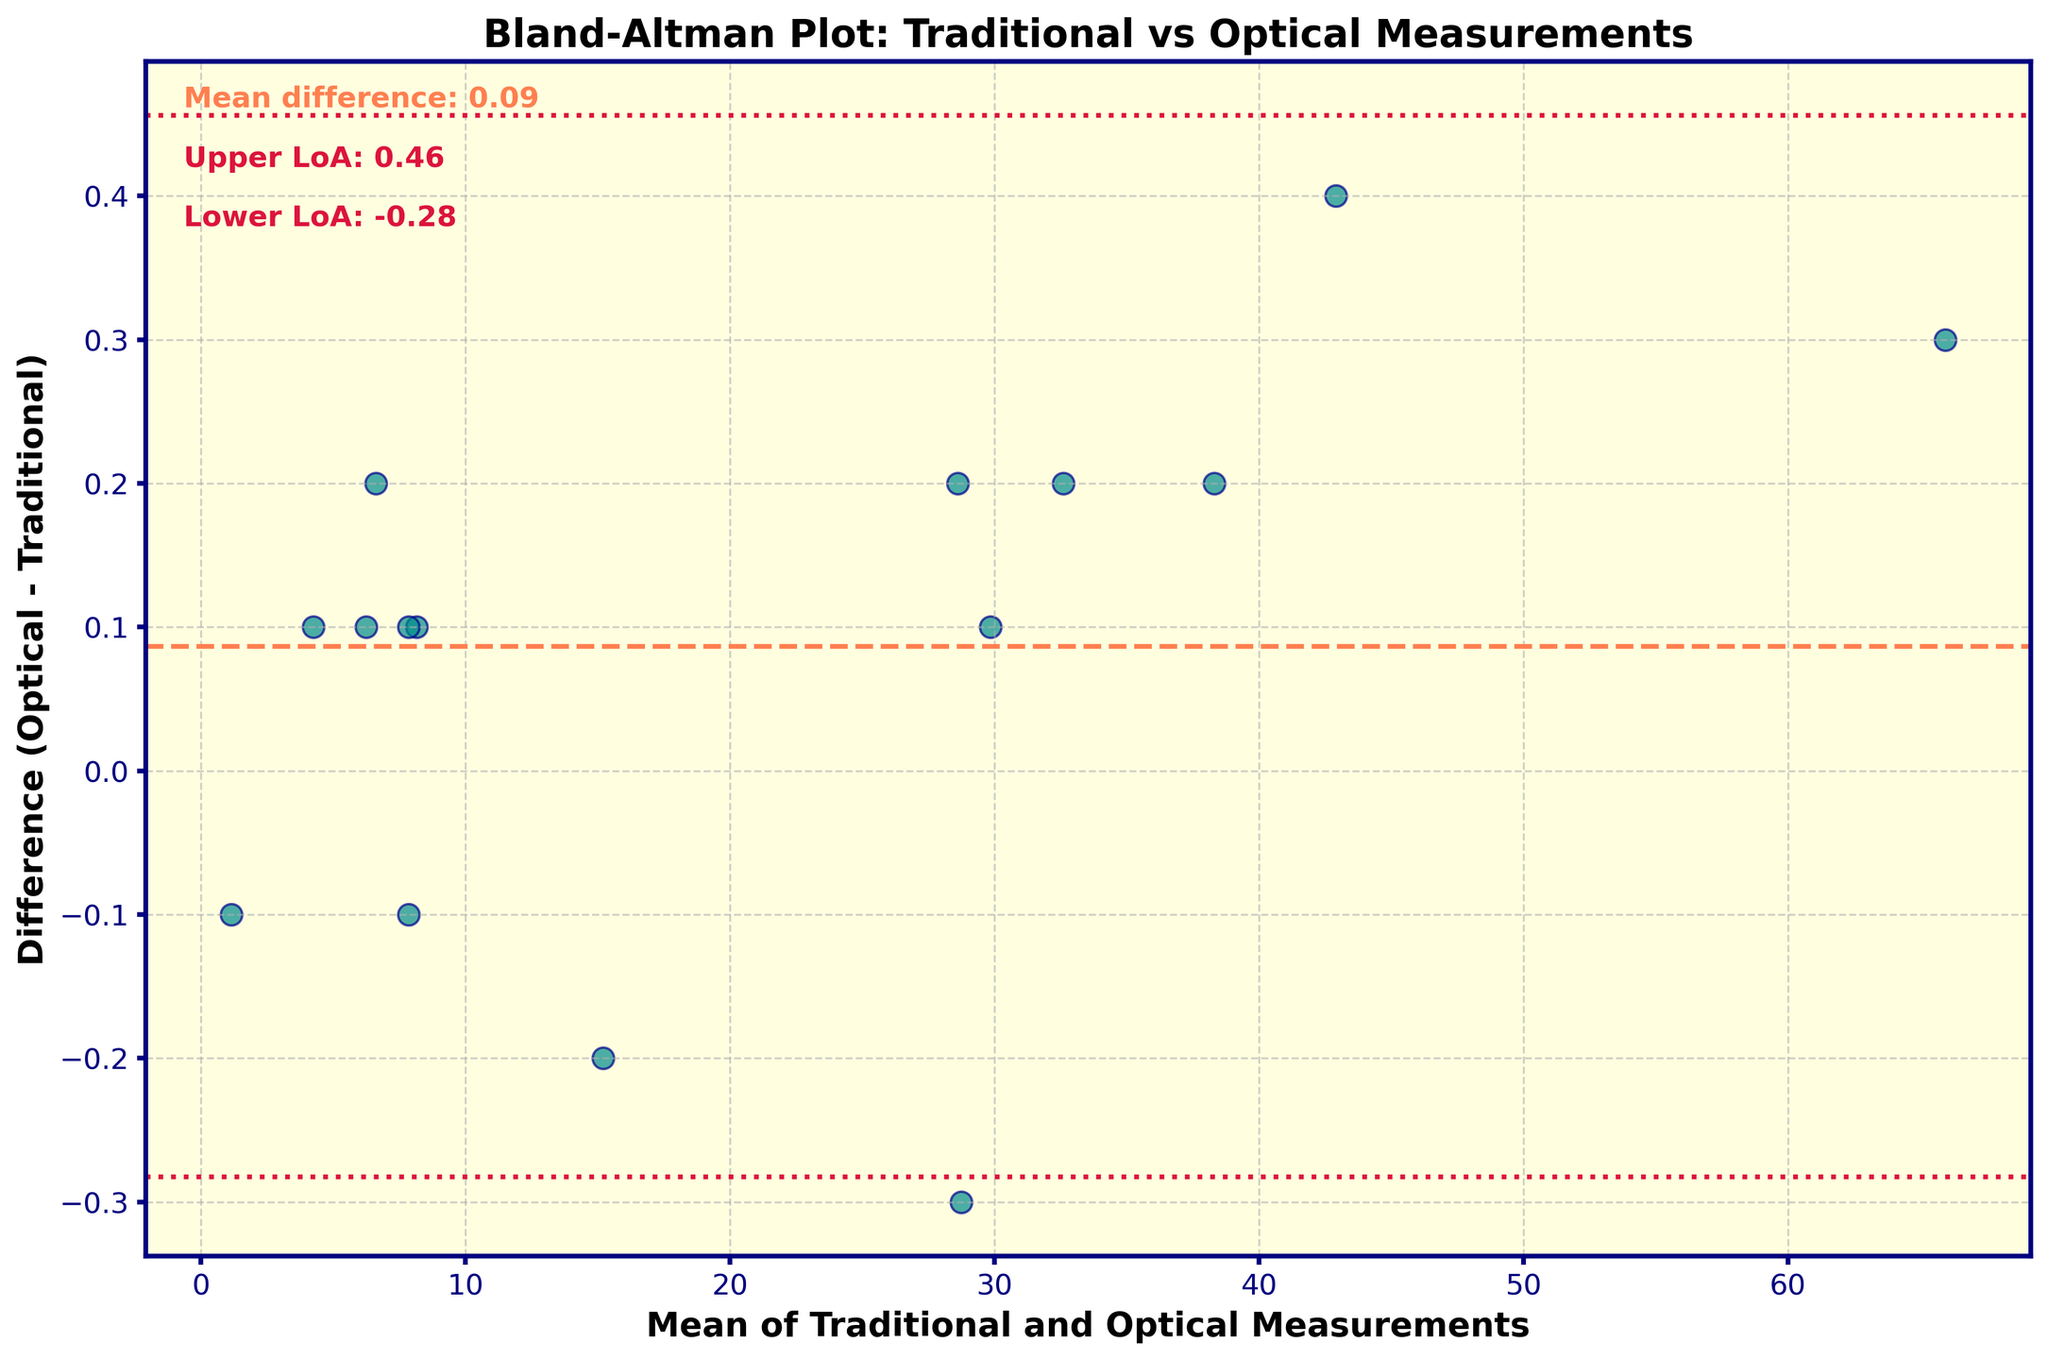How many data points are represented in the plot? By counting each unique scatter point on the plot, we can determine the total number of data points which reflect distinct measurements of water parameters.
Answer: 14 What does the coral-colored dashed line represent? The coral-colored dashed line is placed at the mean difference between the optical and traditional measurements. This helps in understanding the average bias between the two methods.
Answer: Mean difference What are the values of the upper and lower limits of agreement? The upper and lower limits of agreement are represented by the crimson dashed lines. By reading the values on the y-axis where these lines intersect, we can determine their numerical values.
Answer: Upper LoA: 0.22, Lower LoA: -0.16 Which type of water parameter appears to have the largest discrepancy between the two measurement techniques? By finding the point with the largest difference on the y-axis and checking its corresponding mean value on the x-axis, we can identify the water parameter with the largest discrepancy.
Answer: Turbidity_River_Mouth How is the variability in differences indicated in this plot? The variability in differences is shown by the spread of points around the mean difference line. A larger spread indicates higher variability.
Answer: Spread of points What is the average difference between the optical and traditional measurements? The average difference is represented by the mean difference line (coral-colored dashed line) on the y-axis. By locating this line, we can read its value.
Answer: 0.03 Which techniques are represented by points around the mean difference and within the limits of agreement? By noting the data points that fall close to the coral-colored mean difference line and within the crimson dashed upper and lower limits of agreement lines, we can identify the specific water parameter techniques.
Answer: Most techniques except Turbidity_River_Mouth Compare the largest positive and negative differences observed in the figure. What do they represent? By identifying the highest and lowest points on the plot, we can find the largest positive and negative differences respectively. They represent the most significant overestimation and underestimation by the optical technique relative to the traditional measurement.
Answer: Turbidity_River_Mouth (largest positive), pH_Kelp_Forest (largest negative) Is there any indication of a systematic bias in the different measurement methods? A systematic bias would be indicated by a consistent pattern where most points lie either above or below the mean difference line. By observing the location of points relative to the mean difference line, we can determine if a systematic bias exists.
Answer: No systematic bias 